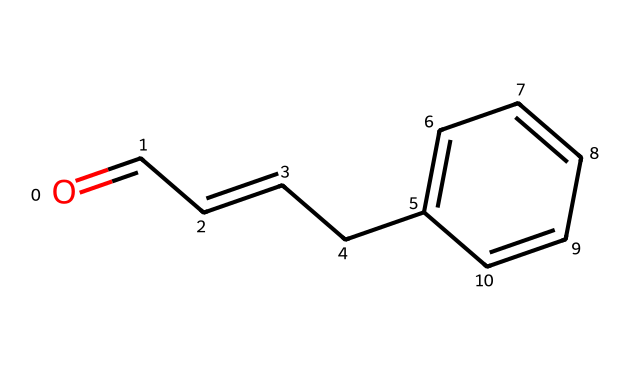What is the molecular formula of cinnamaldehyde? The molecular formula can be derived from the SMILES representation by counting the carbon (C), hydrogen (H), and oxygen (O) atoms present. In this case, there are 9 carbon atoms, 8 hydrogen atoms, and 1 oxygen atom. Therefore, the molecular formula is C9H8O.
Answer: C9H8O How many rings are present in the structure of cinnamaldehyde? By examining the SMILES representation, it shows a linear structure with a benzene ring (a cyclic structure), but there are no additional rings around the carbon chain. Thus, there is 1 ring present in the chemical structure.
Answer: 1 What is the functional group present in cinnamaldehyde? The structure contains an aldehyde functional group, as indicated by the presence of the carbonyl group (C=O) attached to a carbon atom that is also attached to a hydrogen atom at the end of the chain.
Answer: aldehyde Is cinnamaldehyde aromatic? The presence of a benzene ring indicates that the compound possesses aromatic characteristics due to its planar structure and delocalized pi electrons within the ring. This confirms that cinnamaldehyde is indeed aromatic.
Answer: yes Which part of the molecule is responsible for its fungicidal properties? The aldehyde group in cinnamaldehyde is known to be responsible for its antimicrobial activity, including fungicidal properties, due to its ability to disrupt the cell membrane of fungi.
Answer: aldehyde group How many double bonds are present in cinnamaldehyde? Counting the double bonds in the structure as derived from the SMILES code, there are 2 double bonds; one in the aldehyde and one in the carbon-carbon double bond within the chain.
Answer: 2 